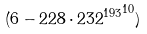Convert formula to latex. <formula><loc_0><loc_0><loc_500><loc_500>( 6 - 2 2 8 \cdot { 2 3 2 ^ { 1 9 3 } } ^ { 1 0 } )</formula> 